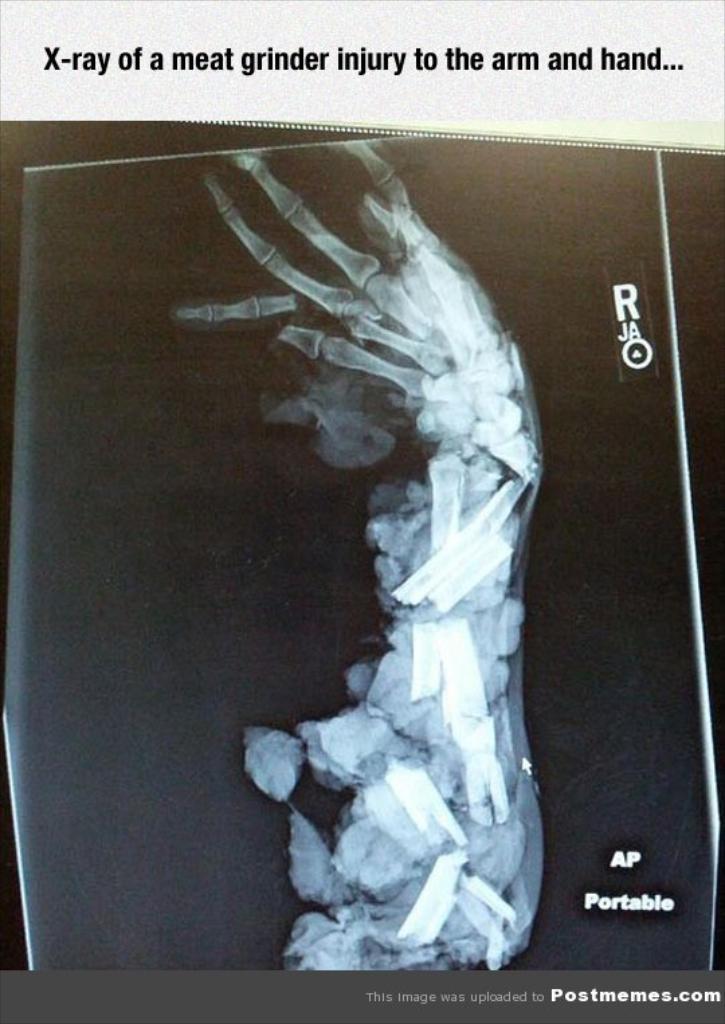Describe this image in one or two sentences. It is a poster. In this image, we can see the x-ray and text. 